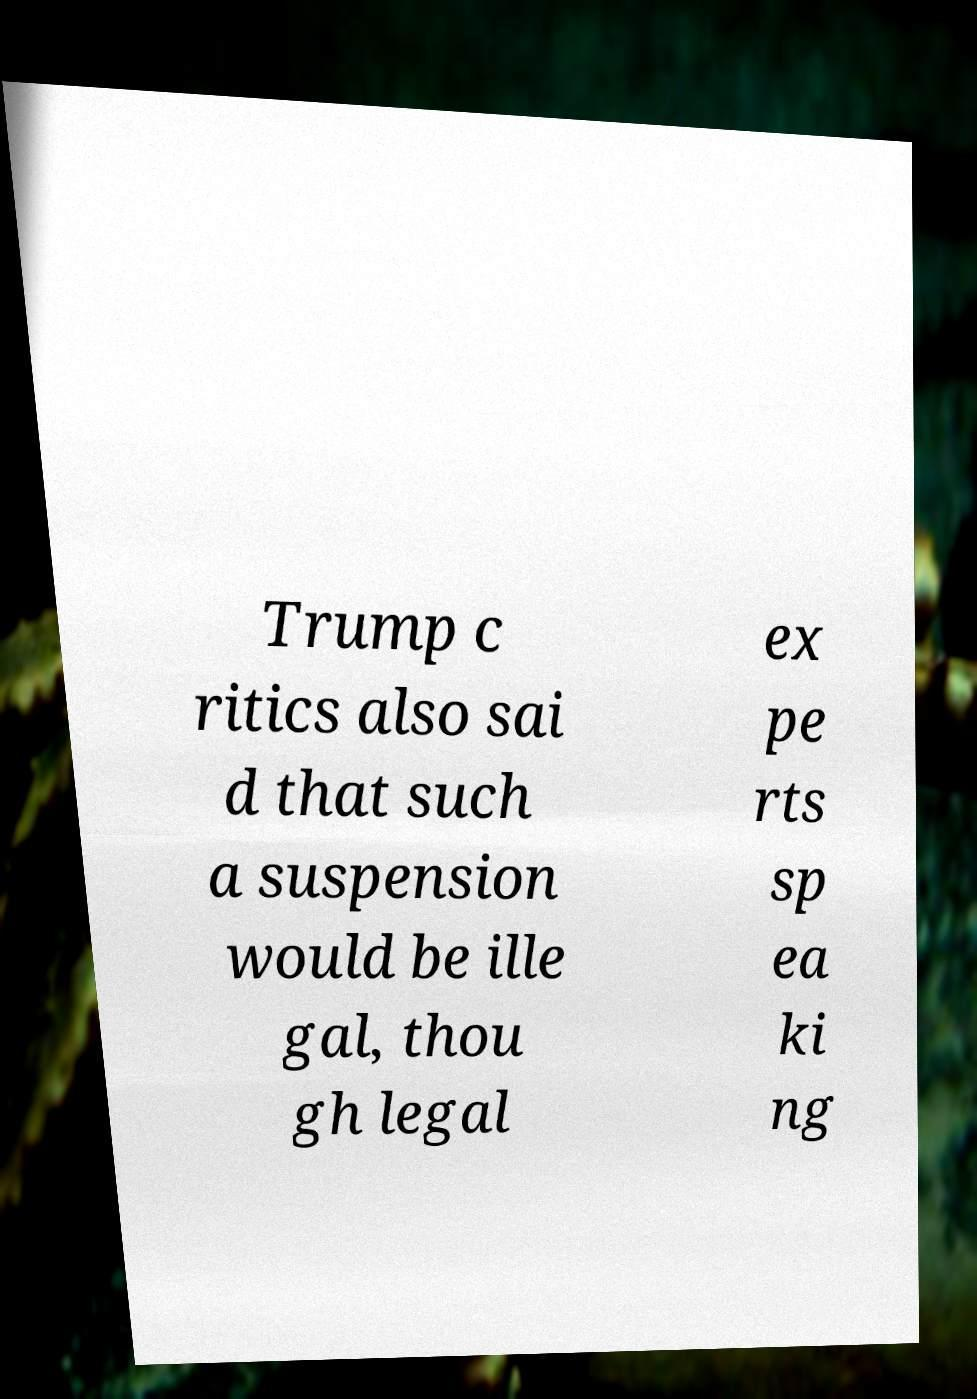For documentation purposes, I need the text within this image transcribed. Could you provide that? Trump c ritics also sai d that such a suspension would be ille gal, thou gh legal ex pe rts sp ea ki ng 